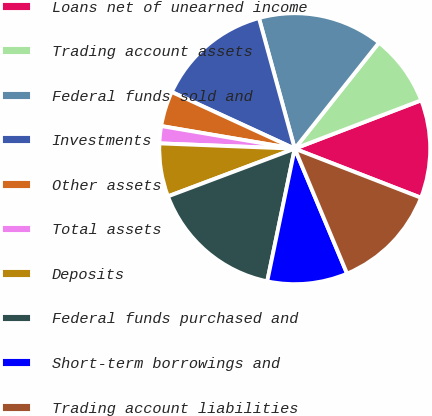<chart> <loc_0><loc_0><loc_500><loc_500><pie_chart><fcel>Loans net of unearned income<fcel>Trading account assets<fcel>Federal funds sold and<fcel>Investments<fcel>Other assets<fcel>Total assets<fcel>Deposits<fcel>Federal funds purchased and<fcel>Short-term borrowings and<fcel>Trading account liabilities<nl><fcel>11.72%<fcel>8.5%<fcel>14.94%<fcel>13.87%<fcel>4.2%<fcel>2.05%<fcel>6.35%<fcel>16.02%<fcel>9.57%<fcel>12.79%<nl></chart> 